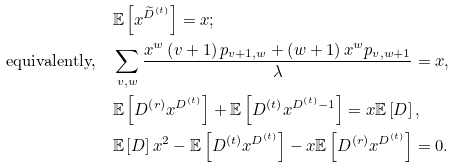Convert formula to latex. <formula><loc_0><loc_0><loc_500><loc_500>& \mathbb { E } \left [ { x } ^ { \widetilde { D } ^ { \left ( t \right ) } } \right ] = x ; \\ \text {equivalently,} \quad & \sum _ { v , w } \frac { { x } ^ { w } \left ( v + 1 \right ) { p } _ { v + 1 , w } + \left ( w + 1 \right ) { x } ^ { w } { p } _ { v , w + 1 } } { \lambda } = x , \\ & \mathbb { E } \left [ { D } ^ { \left ( r \right ) } { x } ^ { { D } ^ { \left ( t \right ) } } \right ] + \mathbb { E } \left [ { D } ^ { \left ( t \right ) } { x } ^ { { D } ^ { \left ( t \right ) } - 1 } \right ] = x \mathbb { E } \left [ D \right ] , \\ & \mathbb { E } \left [ D \right ] { x } ^ { 2 } - \mathbb { E } \left [ { D } ^ { \left ( t \right ) } { x } ^ { { D } ^ { \left ( t \right ) } } \right ] - x \mathbb { E } \left [ { D } ^ { \left ( r \right ) } { x } ^ { { D } ^ { \left ( t \right ) } } \right ] = 0 .</formula> 